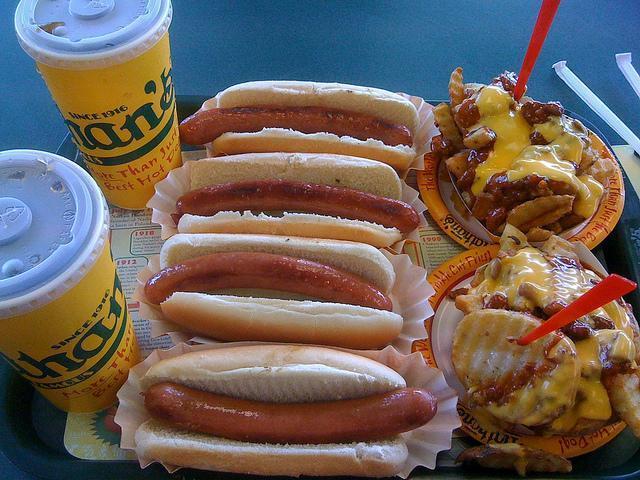How many hot dogs can be seen?
Give a very brief answer. 4. How many cups are there?
Give a very brief answer. 2. How many blue cars are there?
Give a very brief answer. 0. 